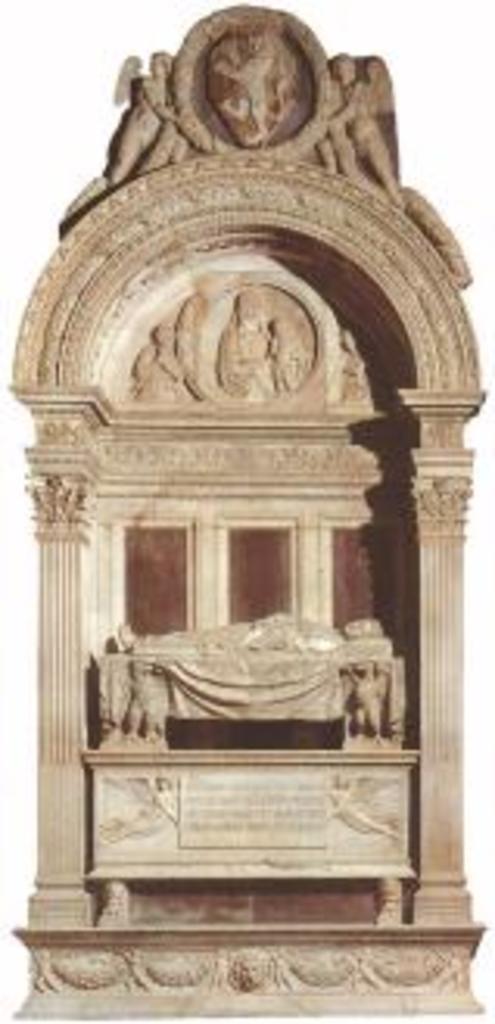Could you give a brief overview of what you see in this image? There is a carving on a stone. There is a white background. 